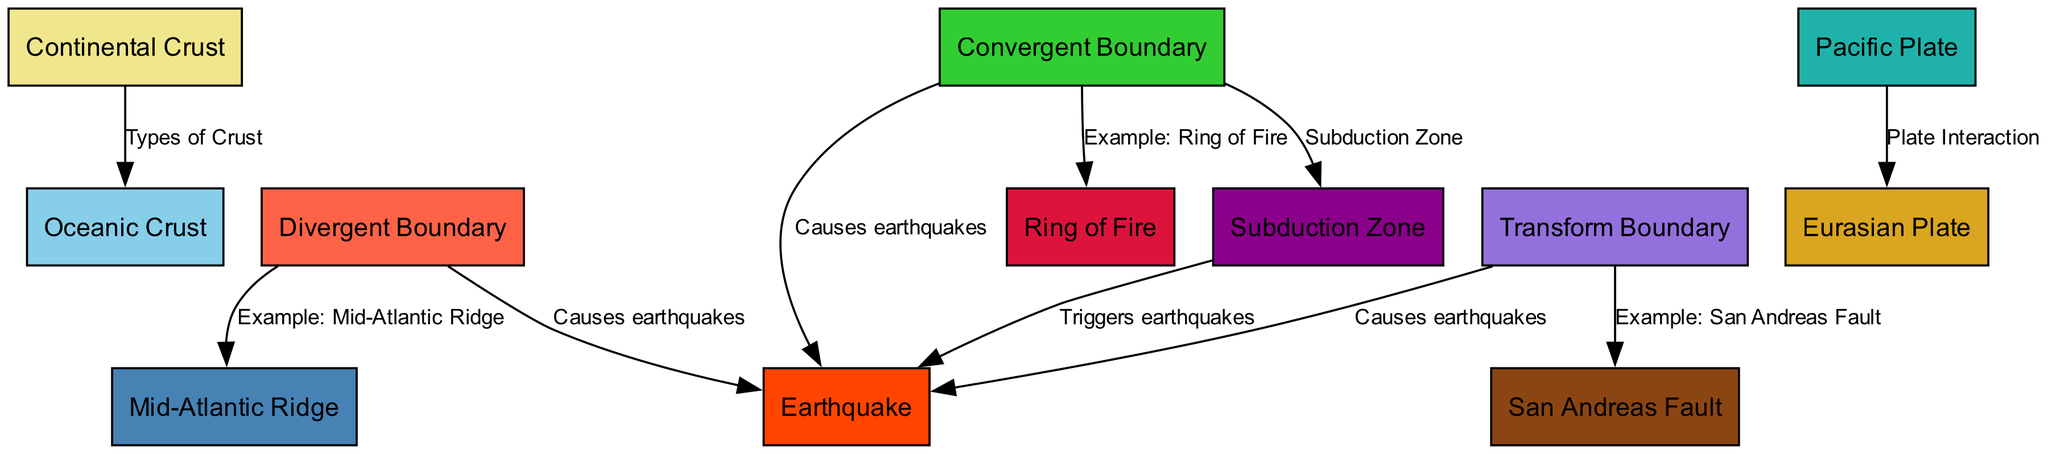What are the two types of crust represented in the diagram? The diagram shows two types of crust: continental crust and oceanic crust. These are labeled as separate nodes in the diagram, clearly indicating the distinction.
Answer: Continental Crust, Oceanic Crust How many examples of boundaries are shown in the diagram? There are three types of boundaries illustrated in the diagram: divergent boundary, convergent boundary, and transform boundary. Each boundary type is connected to examples located in the diagram.
Answer: 3 Which boundary causes earthquakes? The diagram indicates that divergent, convergent, and transform boundaries are all labeled with edges stating that they cause earthquakes. Thus, all three types of boundaries contribute to seismic activity.
Answer: Divergent, Convergent, Transform What is an example of a divergent boundary? According to the diagram, the Mid-Atlantic Ridge is given as an example of a divergent boundary. This relation is shown in the edge connecting the divergent boundary node to the Mid-Atlantic Ridge node.
Answer: Mid-Atlantic Ridge Which two plates interact at the San Andreas Fault? The diagram shows that the Pacific Plate and the Eurasian Plate interact at the San Andreas Fault, indicating the tectonic activity between these plates in that region.
Answer: Pacific Plate, Eurasian Plate What relationship does the subduction zone have with earthquakes? The diagram specifies that the subduction zone triggers earthquakes, showing that this area is a significant factor contributing to seismic events when plates interact in this manner.
Answer: Triggers earthquakes What geological phenomenon is associated with the Ring of Fire? The diagram connects the Ring of Fire to the convergent boundary, which indicates that it is an example of where significant geological phenomena, like volcanic activity and earthquakes, occur due to converging tectonic plates.
Answer: Example: Ring of Fire 